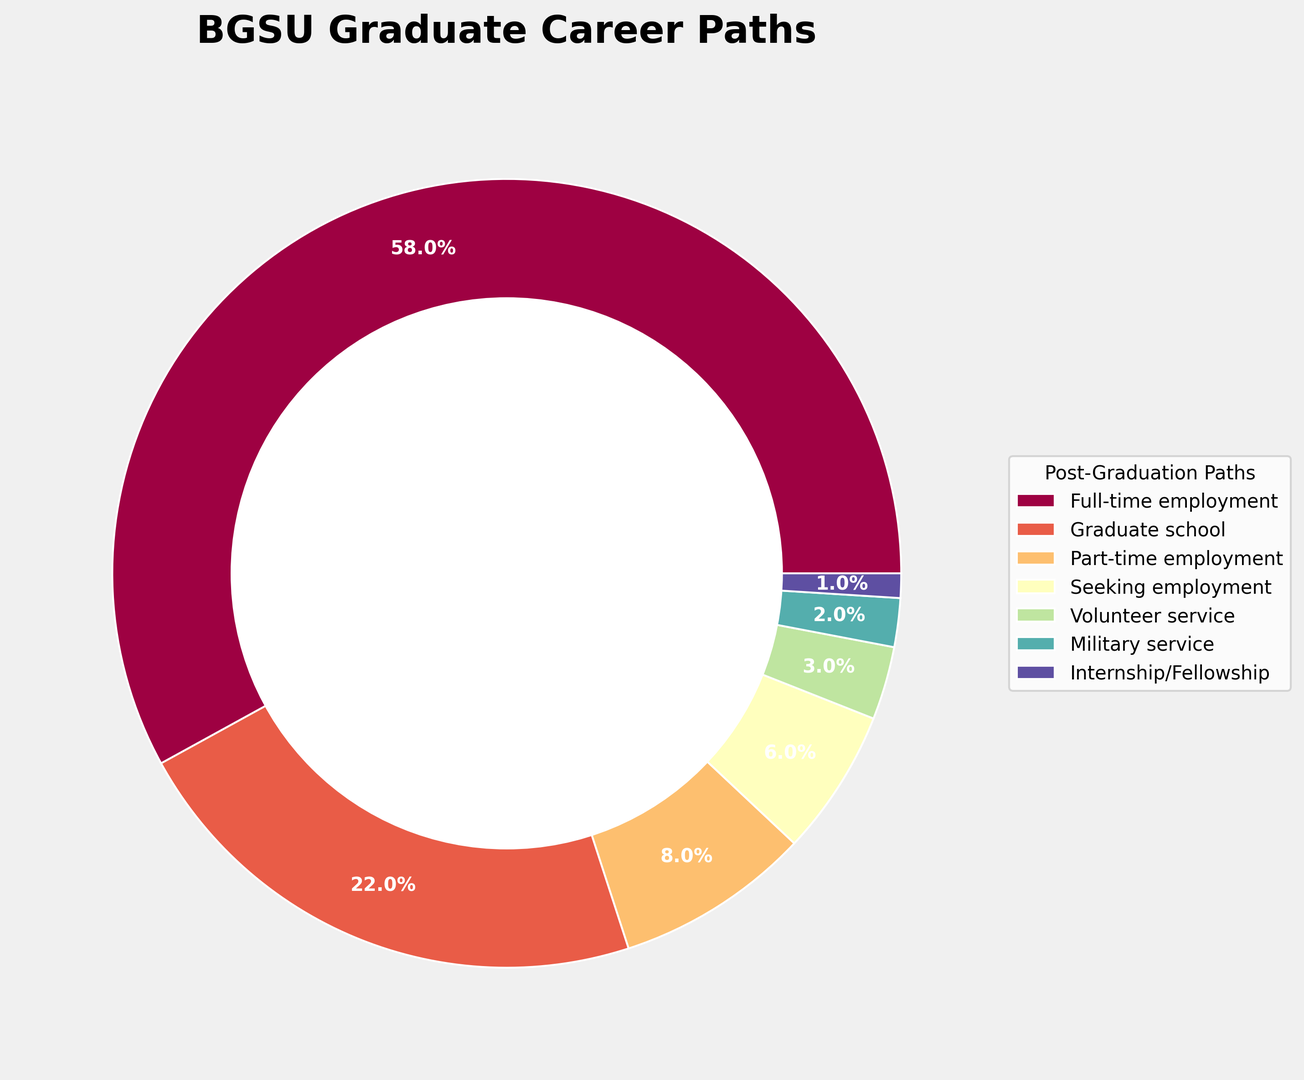What is the most common post-graduation path for BGSU graduates? The path with the highest percentage is full-time employment at 58%. This is clearly the largest section in the ring chart.
Answer: Full-time employment Which post-graduation path has the least number of graduates? The path with the lowest percentage is internship/fellowship at 1%. This is the smallest section in the ring chart.
Answer: Internship/Fellowship How much greater is the percentage of graduates pursuing full-time employment compared to those continuing to graduate school? The percentage of graduates pursuing full-time employment is 58% and those continuing to graduate school is 22%. The difference is calculated as 58 - 22.
Answer: 36% What proportion of graduates are in some form of employment (either full-time or part-time)? Summing the percentages of full-time and part-time employment gives 58% + 8%.
Answer: 66% How many times larger is the proportion of graduates in full-time employment compared to those in military service? The percentage of full-time employment is 58%, and military service is 2%. Dividing 58 by 2 gives the ratio.
Answer: 29 times larger Which path is more common: part-time employment or seeking employment? Part-time employment has 8%, while seeking employment has 6%. Part-time employment has a higher percentage.
Answer: Part-time employment Is the proportion of graduates going to volunteer service more than or less than half of those going to graduate school? The proportion going to graduate school is 22%, and half of that is 11%. Volunteer service is at 3%, which is less than 11%.
Answer: Less than half What combined percentage of graduates are either seeking employment or in part-time employment? Adding the percentages for seeking employment (6%) and part-time employment (8%) gives 6 + 8.
Answer: 14% How do the proportions of military service and volunteer service compare? Military service accounts for 2% and volunteer service accounts for 3%. Therefore, volunteer service has a higher percentage.
Answer: Volunteer service is higher What are the second and third most common post-graduation paths for BGSU graduates? The second most common path is graduate school at 22%, and the third most common path is part-time employment at 8%, as shown in the ring chart.
Answer: Graduate school and Part-time employment 